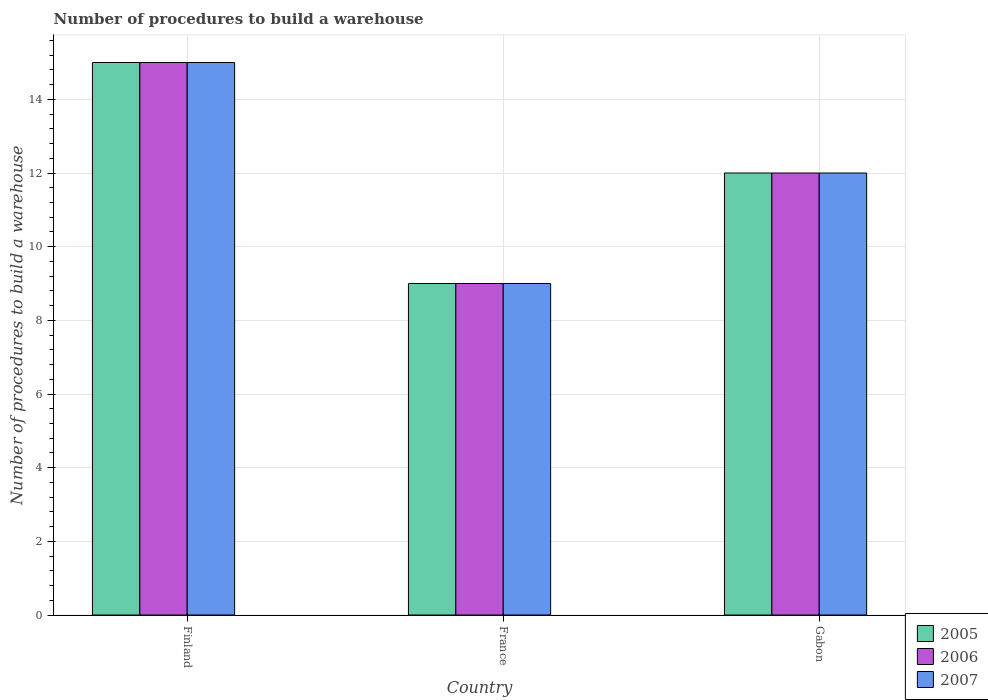How many different coloured bars are there?
Your answer should be very brief. 3. Are the number of bars per tick equal to the number of legend labels?
Keep it short and to the point. Yes. Are the number of bars on each tick of the X-axis equal?
Your response must be concise. Yes. How many bars are there on the 3rd tick from the left?
Make the answer very short. 3. In how many cases, is the number of bars for a given country not equal to the number of legend labels?
Your response must be concise. 0. Across all countries, what is the maximum number of procedures to build a warehouse in in 2005?
Keep it short and to the point. 15. Across all countries, what is the minimum number of procedures to build a warehouse in in 2006?
Offer a terse response. 9. In which country was the number of procedures to build a warehouse in in 2005 maximum?
Keep it short and to the point. Finland. In which country was the number of procedures to build a warehouse in in 2006 minimum?
Your answer should be very brief. France. What is the difference between the number of procedures to build a warehouse in in 2006 in France and that in Gabon?
Your answer should be compact. -3. What is the difference between the number of procedures to build a warehouse in in 2006 in Gabon and the number of procedures to build a warehouse in in 2005 in France?
Give a very brief answer. 3. What is the average number of procedures to build a warehouse in in 2005 per country?
Ensure brevity in your answer.  12. What is the ratio of the number of procedures to build a warehouse in in 2006 in Finland to that in France?
Provide a succinct answer. 1.67. Is the number of procedures to build a warehouse in in 2005 in Finland less than that in France?
Provide a short and direct response. No. What is the difference between the highest and the lowest number of procedures to build a warehouse in in 2005?
Your answer should be compact. 6. In how many countries, is the number of procedures to build a warehouse in in 2005 greater than the average number of procedures to build a warehouse in in 2005 taken over all countries?
Provide a short and direct response. 1. Is the sum of the number of procedures to build a warehouse in in 2007 in Finland and Gabon greater than the maximum number of procedures to build a warehouse in in 2006 across all countries?
Provide a succinct answer. Yes. What does the 1st bar from the left in Finland represents?
Your response must be concise. 2005. What does the 1st bar from the right in Finland represents?
Make the answer very short. 2007. How many countries are there in the graph?
Provide a short and direct response. 3. Are the values on the major ticks of Y-axis written in scientific E-notation?
Provide a short and direct response. No. What is the title of the graph?
Provide a short and direct response. Number of procedures to build a warehouse. What is the label or title of the X-axis?
Offer a terse response. Country. What is the label or title of the Y-axis?
Your answer should be very brief. Number of procedures to build a warehouse. What is the Number of procedures to build a warehouse of 2005 in Finland?
Your answer should be very brief. 15. What is the Number of procedures to build a warehouse of 2007 in France?
Provide a short and direct response. 9. What is the Number of procedures to build a warehouse in 2006 in Gabon?
Your answer should be very brief. 12. What is the Number of procedures to build a warehouse in 2007 in Gabon?
Your response must be concise. 12. Across all countries, what is the maximum Number of procedures to build a warehouse of 2005?
Make the answer very short. 15. Across all countries, what is the maximum Number of procedures to build a warehouse in 2006?
Give a very brief answer. 15. Across all countries, what is the maximum Number of procedures to build a warehouse of 2007?
Offer a very short reply. 15. Across all countries, what is the minimum Number of procedures to build a warehouse in 2005?
Offer a very short reply. 9. Across all countries, what is the minimum Number of procedures to build a warehouse in 2006?
Give a very brief answer. 9. Across all countries, what is the minimum Number of procedures to build a warehouse in 2007?
Provide a succinct answer. 9. What is the total Number of procedures to build a warehouse in 2005 in the graph?
Offer a very short reply. 36. What is the total Number of procedures to build a warehouse of 2007 in the graph?
Your answer should be very brief. 36. What is the difference between the Number of procedures to build a warehouse in 2005 in Finland and that in France?
Offer a terse response. 6. What is the difference between the Number of procedures to build a warehouse in 2005 in Finland and that in Gabon?
Offer a terse response. 3. What is the difference between the Number of procedures to build a warehouse in 2006 in Finland and that in Gabon?
Ensure brevity in your answer.  3. What is the difference between the Number of procedures to build a warehouse in 2005 in France and that in Gabon?
Ensure brevity in your answer.  -3. What is the difference between the Number of procedures to build a warehouse in 2006 in France and that in Gabon?
Your answer should be compact. -3. What is the difference between the Number of procedures to build a warehouse of 2005 in Finland and the Number of procedures to build a warehouse of 2007 in France?
Offer a very short reply. 6. What is the difference between the Number of procedures to build a warehouse in 2005 in Finland and the Number of procedures to build a warehouse in 2007 in Gabon?
Your answer should be very brief. 3. What is the difference between the Number of procedures to build a warehouse in 2006 in Finland and the Number of procedures to build a warehouse in 2007 in Gabon?
Your answer should be very brief. 3. What is the difference between the Number of procedures to build a warehouse in 2005 in France and the Number of procedures to build a warehouse in 2006 in Gabon?
Your response must be concise. -3. What is the difference between the Number of procedures to build a warehouse in 2005 in France and the Number of procedures to build a warehouse in 2007 in Gabon?
Offer a very short reply. -3. What is the average Number of procedures to build a warehouse of 2005 per country?
Ensure brevity in your answer.  12. What is the average Number of procedures to build a warehouse in 2006 per country?
Your answer should be compact. 12. What is the difference between the Number of procedures to build a warehouse in 2005 and Number of procedures to build a warehouse in 2007 in Finland?
Provide a succinct answer. 0. What is the difference between the Number of procedures to build a warehouse in 2006 and Number of procedures to build a warehouse in 2007 in Finland?
Keep it short and to the point. 0. What is the difference between the Number of procedures to build a warehouse in 2005 and Number of procedures to build a warehouse in 2007 in France?
Give a very brief answer. 0. What is the difference between the Number of procedures to build a warehouse in 2005 and Number of procedures to build a warehouse in 2007 in Gabon?
Ensure brevity in your answer.  0. What is the difference between the Number of procedures to build a warehouse in 2006 and Number of procedures to build a warehouse in 2007 in Gabon?
Your response must be concise. 0. What is the ratio of the Number of procedures to build a warehouse in 2005 in Finland to that in France?
Provide a succinct answer. 1.67. What is the ratio of the Number of procedures to build a warehouse of 2007 in Finland to that in Gabon?
Make the answer very short. 1.25. What is the ratio of the Number of procedures to build a warehouse of 2006 in France to that in Gabon?
Your answer should be compact. 0.75. What is the difference between the highest and the second highest Number of procedures to build a warehouse of 2005?
Keep it short and to the point. 3. What is the difference between the highest and the second highest Number of procedures to build a warehouse in 2007?
Keep it short and to the point. 3. What is the difference between the highest and the lowest Number of procedures to build a warehouse of 2005?
Offer a very short reply. 6. What is the difference between the highest and the lowest Number of procedures to build a warehouse in 2006?
Provide a short and direct response. 6. What is the difference between the highest and the lowest Number of procedures to build a warehouse in 2007?
Your answer should be compact. 6. 